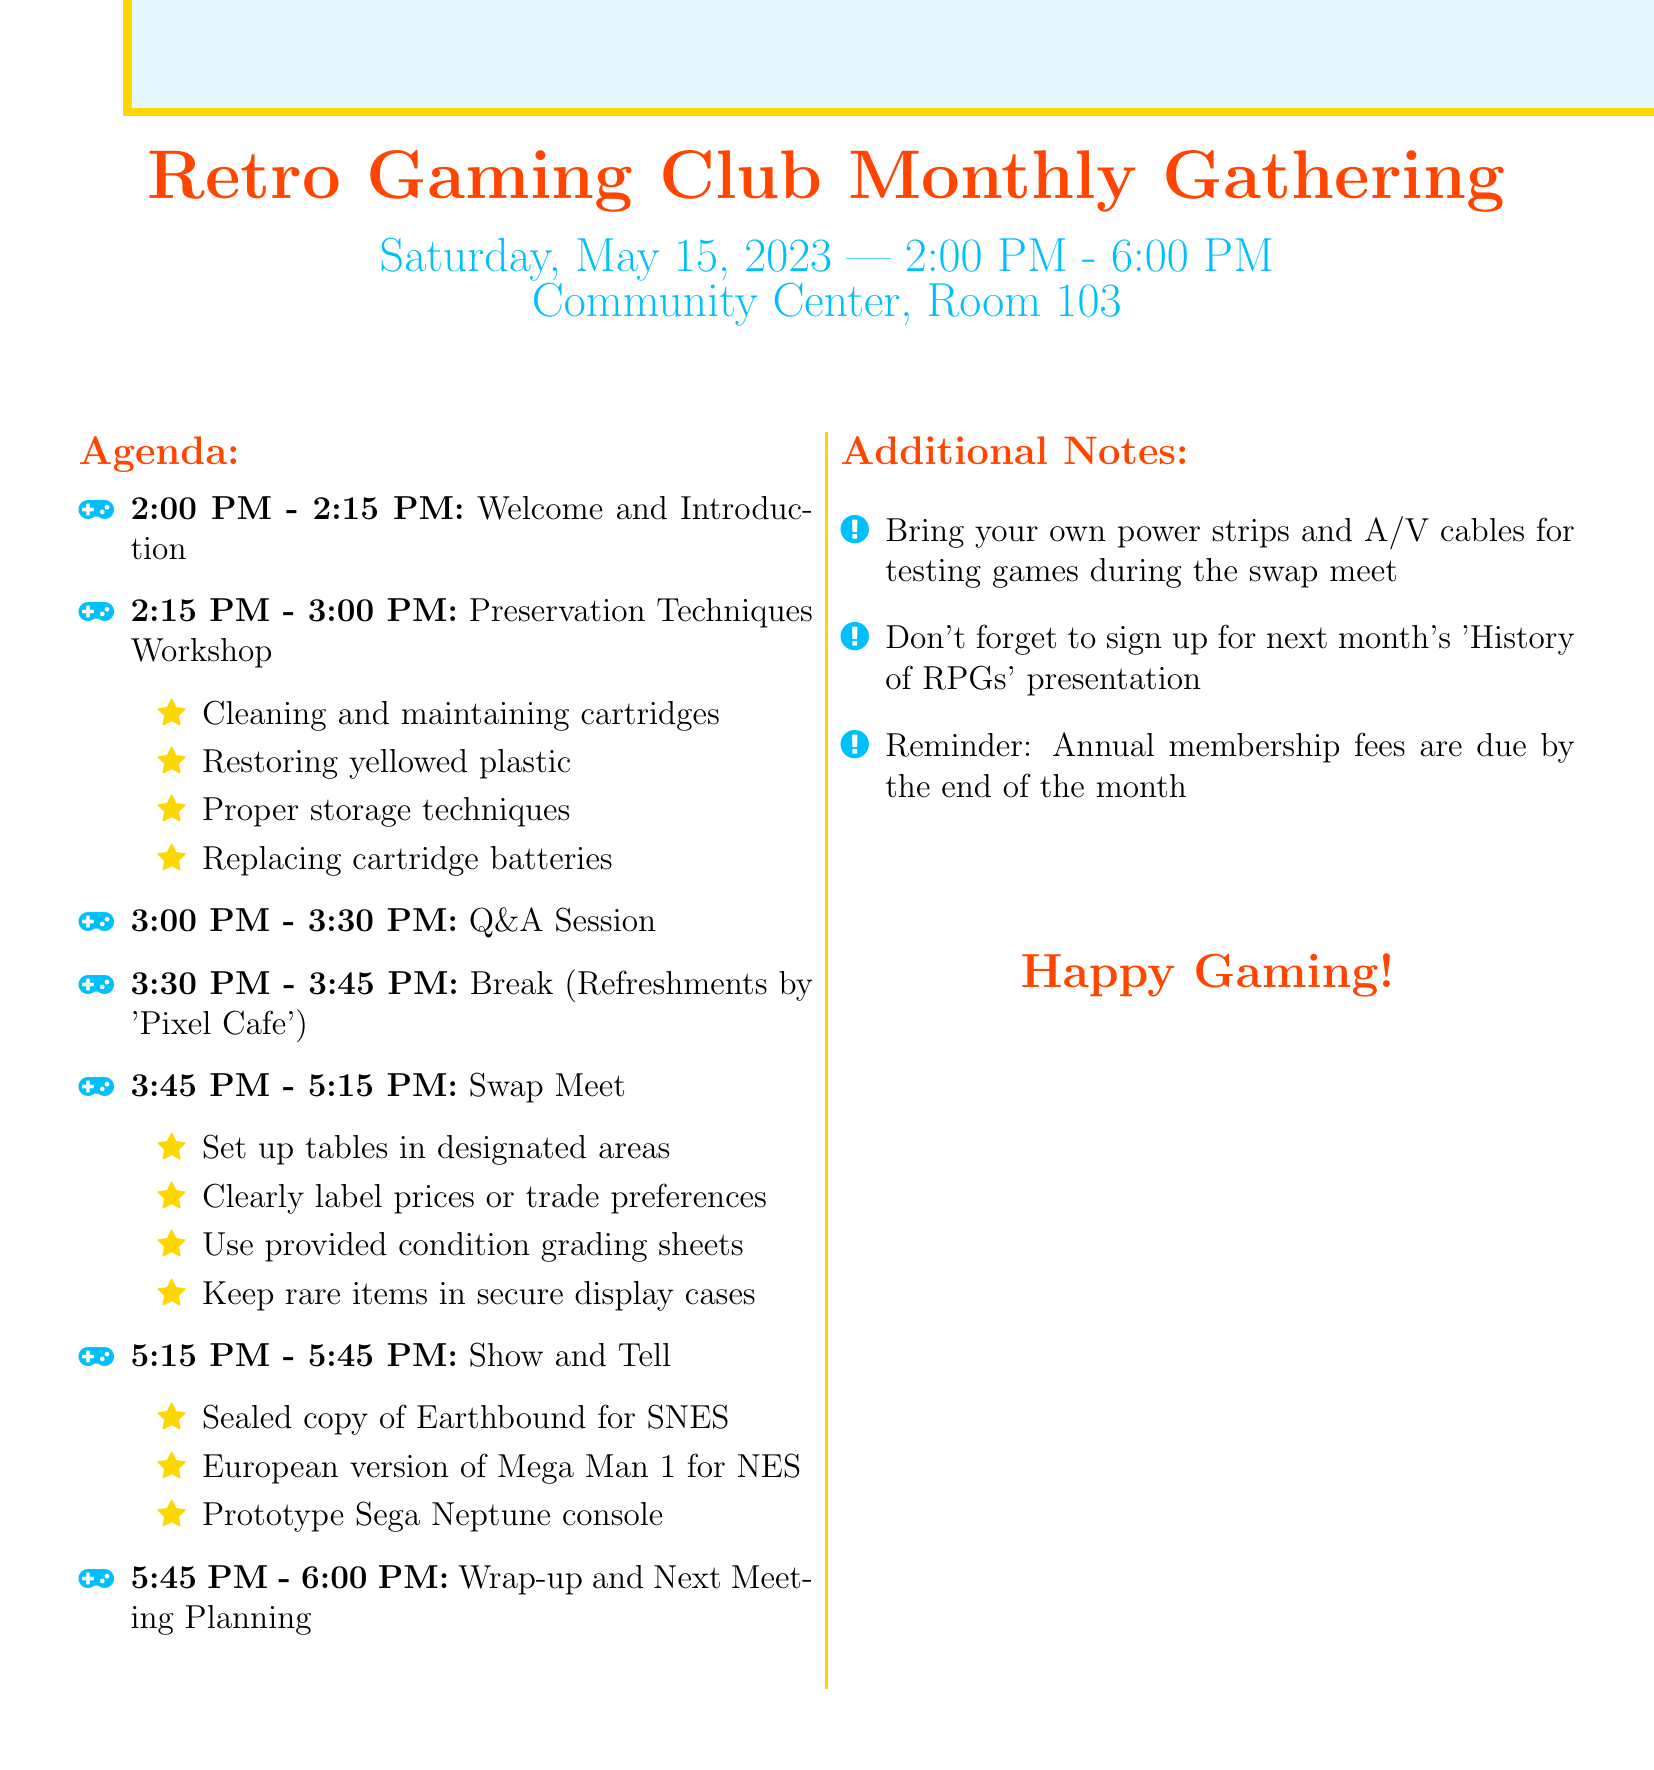What is the meeting title? The meeting title is explicitly mentioned at the beginning of the agenda.
Answer: Retro Gaming Club Monthly Gathering What is the date of the meeting? The date of the meeting is specified as part of the meeting details.
Answer: Saturday, May 15, 2023 Who is the guest speaker for the Preservation Techniques Workshop? The workshop section includes the name of the guest speaker leading the discussion.
Answer: James Chen How long is the Swap Meet scheduled to last? The duration of the Swap Meet is provided in the agenda by calculating the time slots.
Answer: 1 hour 30 minutes What items are featured in the Show and Tell segment? The items in the Show and Tell segment are listed under that activity in the agenda.
Answer: Sealed copy of Earthbound for SNES, European version of Mega Man 1 for NES, Prototype Sega Neptune console What are members encouraged to bring for the Swap Meet? The additional notes section provides essential items that members should bring.
Answer: Power strips and A/V cables How many activities are outlined in the agenda? By counting the activities listed in the agenda section, one can identify the total number.
Answer: 6 activities What is the location of the meeting? The location is clearly presented alongside the date and time at the start of the document.
Answer: Community Center, Room 103 